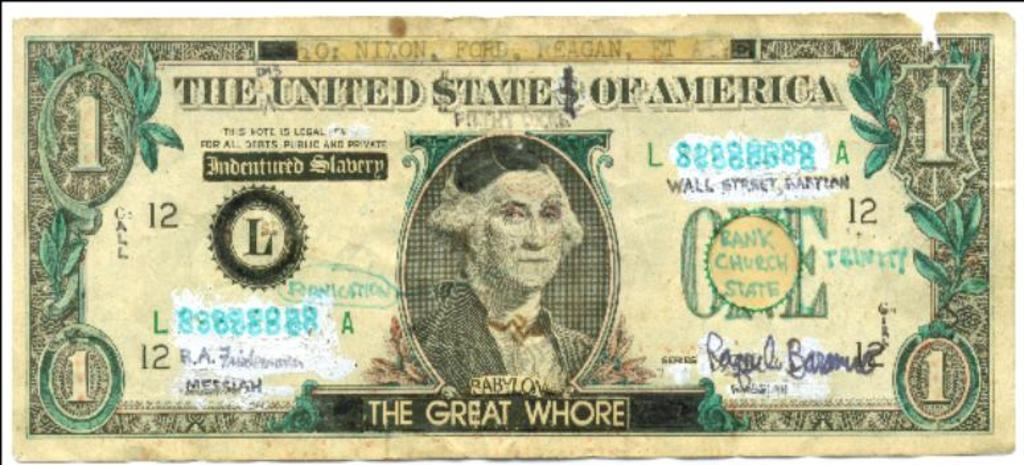<image>
Relay a brief, clear account of the picture shown. Someone has changed a dollar bill to say "the great whore" at the bottom. 